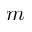Convert formula to latex. <formula><loc_0><loc_0><loc_500><loc_500>m</formula> 